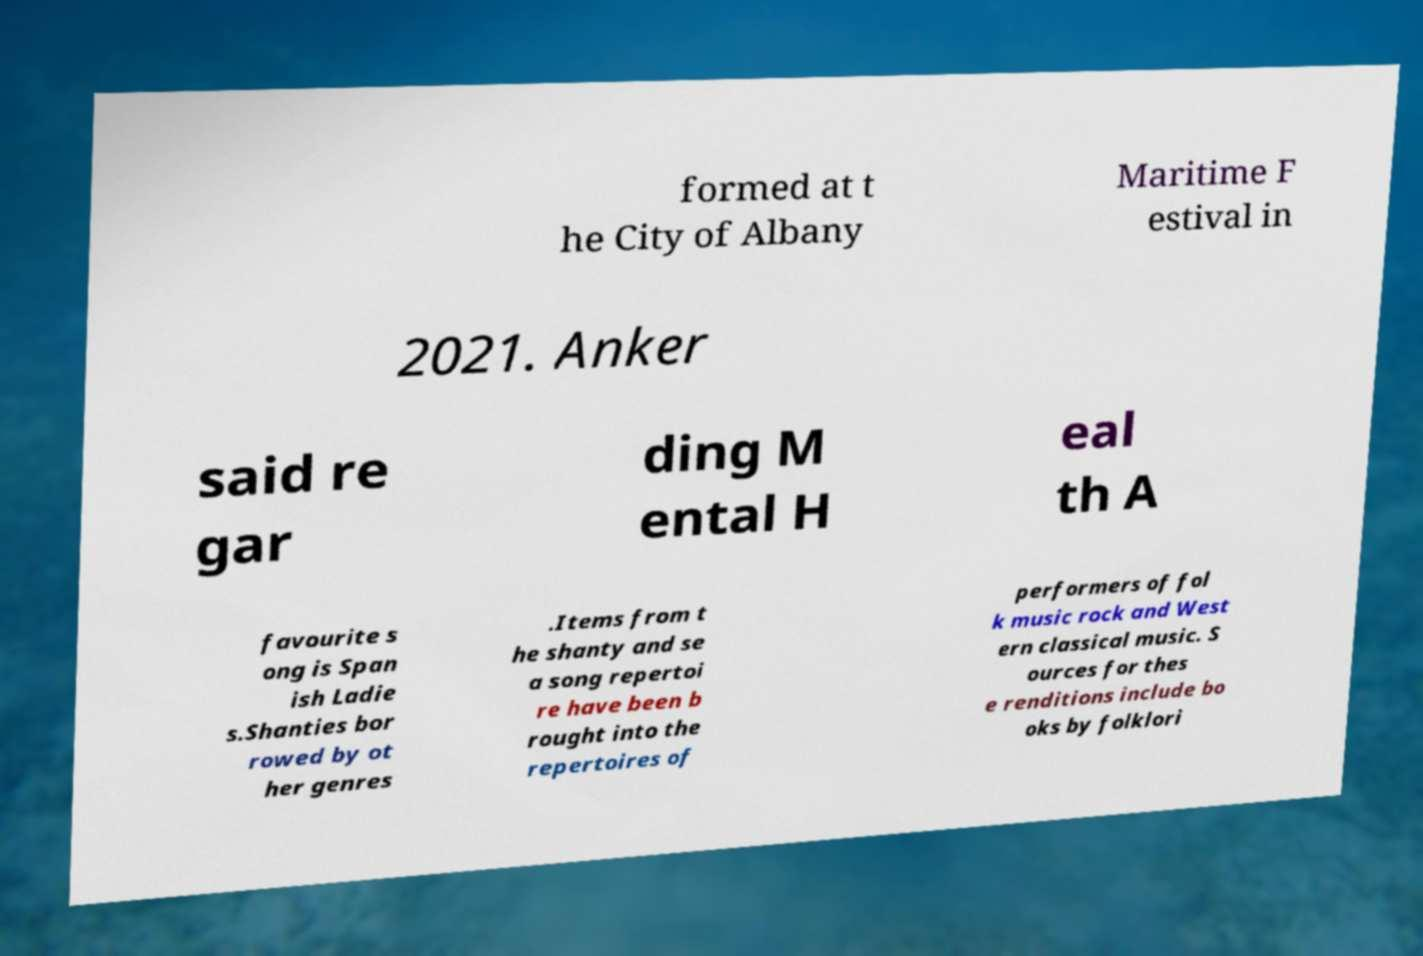Please identify and transcribe the text found in this image. formed at t he City of Albany Maritime F estival in 2021. Anker said re gar ding M ental H eal th A favourite s ong is Span ish Ladie s.Shanties bor rowed by ot her genres .Items from t he shanty and se a song repertoi re have been b rought into the repertoires of performers of fol k music rock and West ern classical music. S ources for thes e renditions include bo oks by folklori 